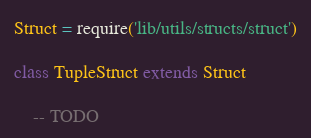<code> <loc_0><loc_0><loc_500><loc_500><_MoonScript_>Struct = require('lib/utils/structs/struct')

class TupleStruct extends Struct

	-- TODO
</code> 